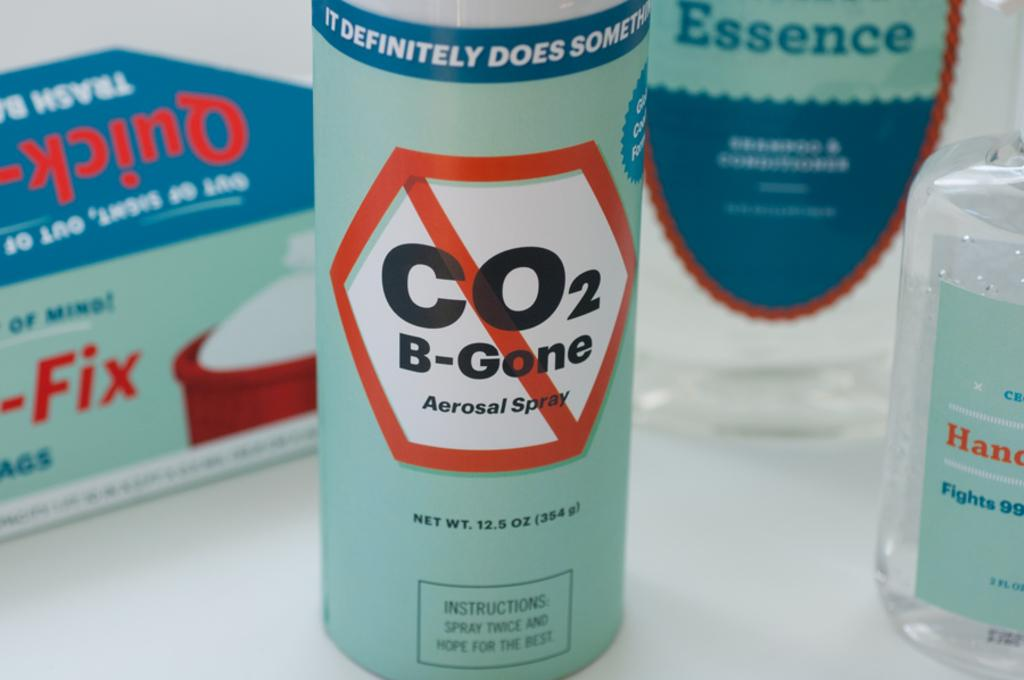<image>
Present a compact description of the photo's key features. Can of B-Gone spray sitting next to hand cleaner and trash bags 